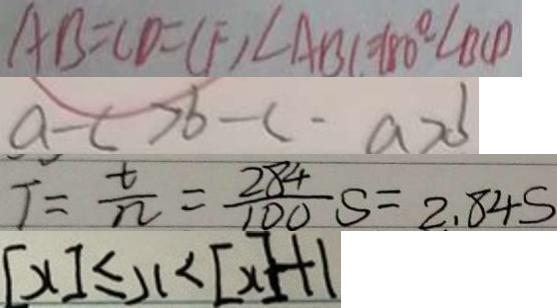Convert formula to latex. <formula><loc_0><loc_0><loc_500><loc_500>A B = C D = C F , \angle A B C = 1 8 0 ^ { \circ } - \angle B C D 
 a - c > b - c - a > b 
 T = \frac { t } { n } = \frac { 2 8 4 } { 1 0 0 } S = 2 . 8 4 S 
 [ x ] \leq x < [ x ] + 1</formula> 